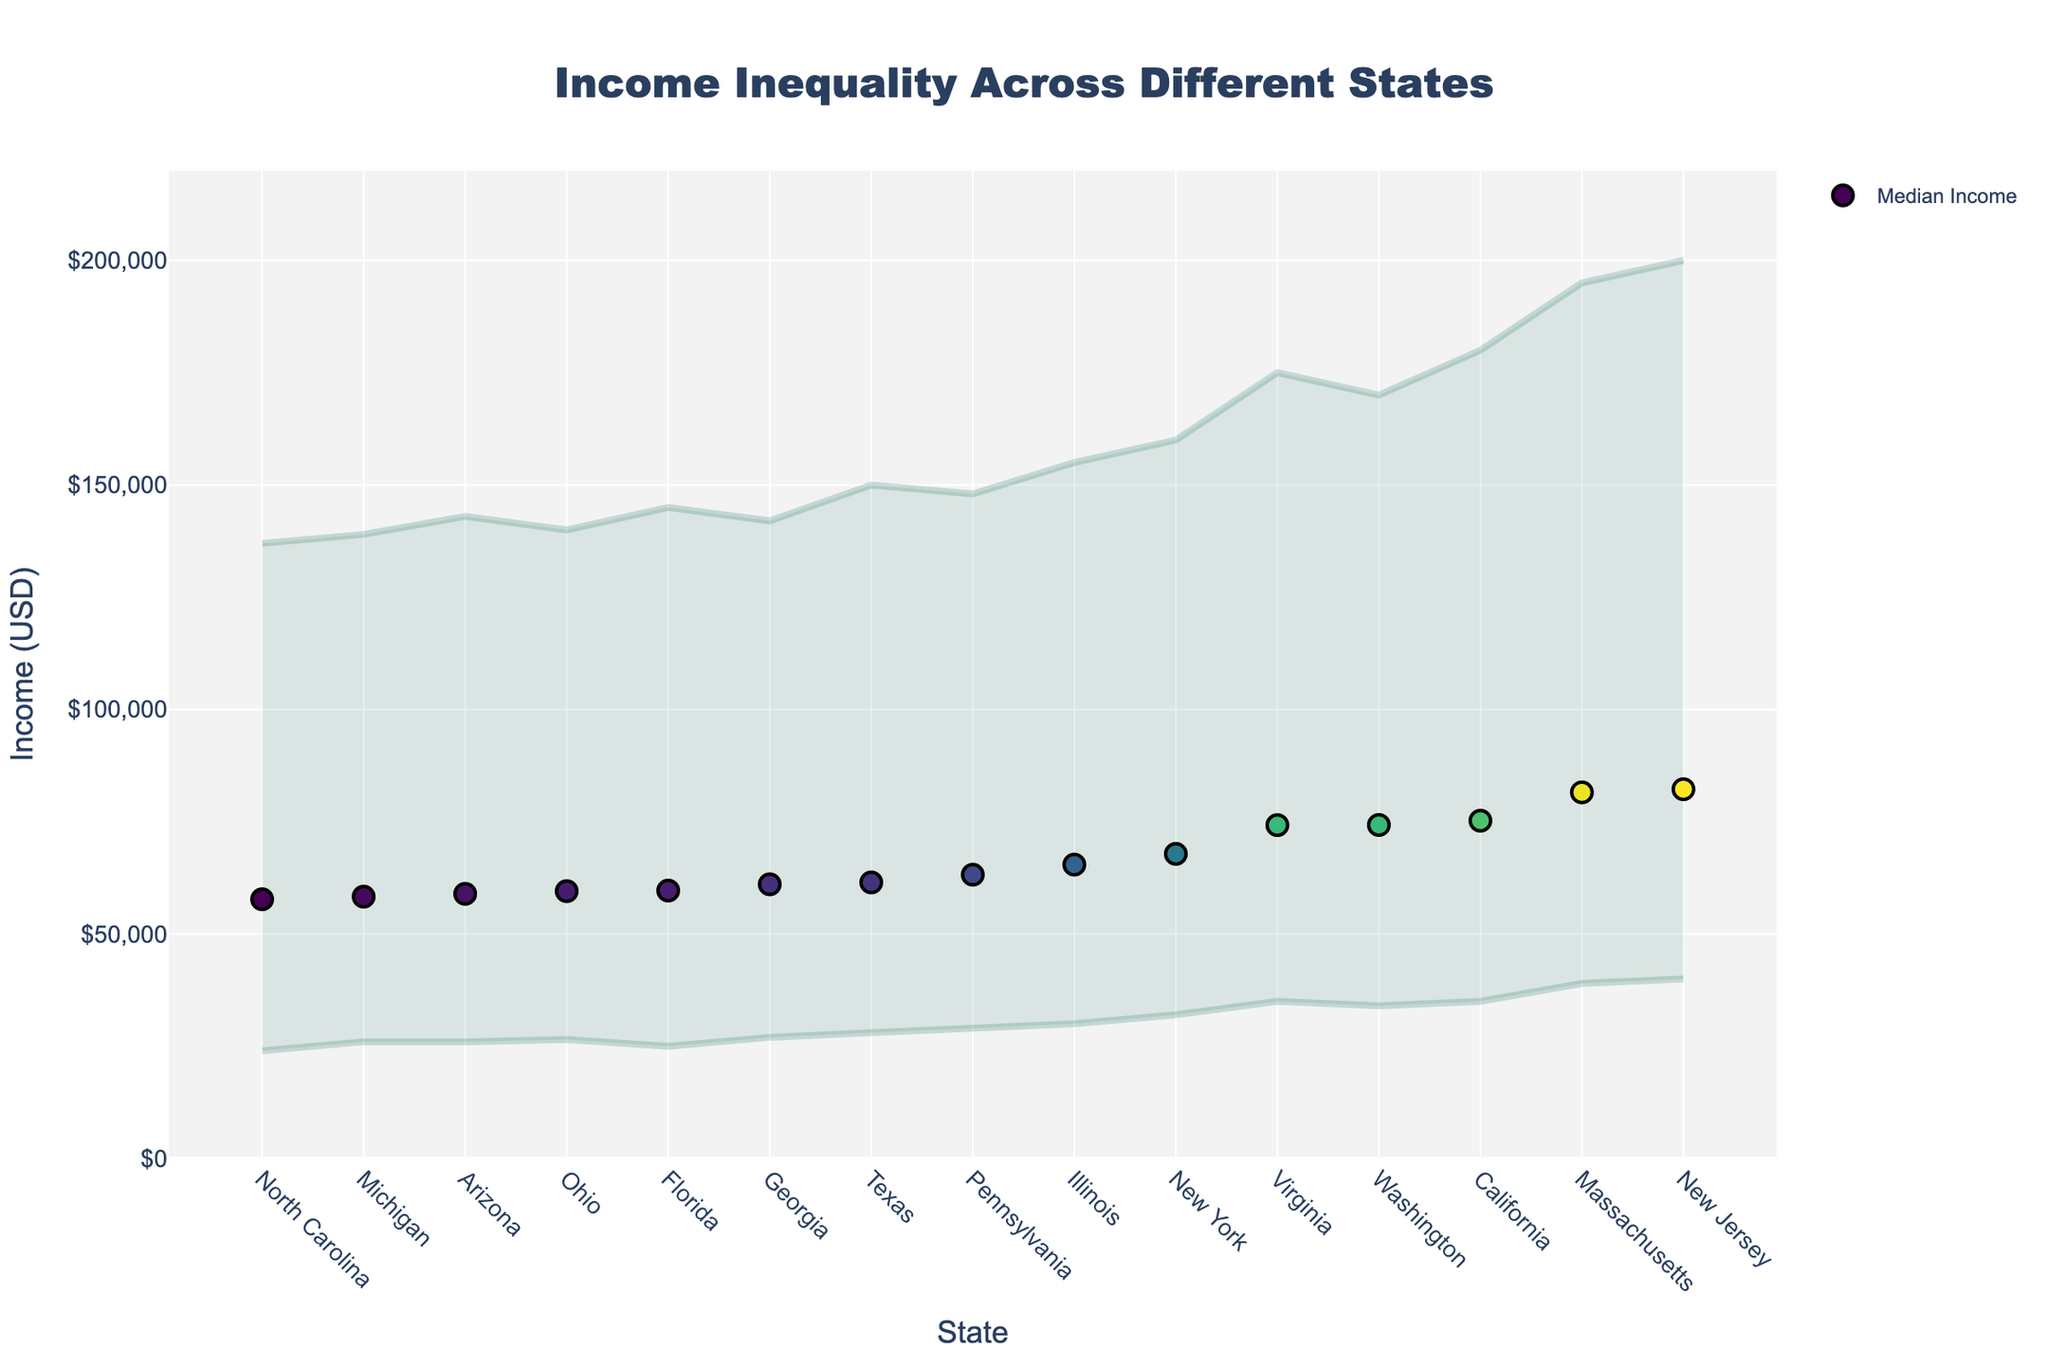what is the title of the figure? The title is usually located at the top of the graph. In this figure, it is clearly stated at the forefront.
Answer: Income Inequality Across Different States Which state has the highest median household income? To find the state with the highest median household income, look for the largest value of the median income on the vertical axis.
Answer: New Jersey What is the median household income for Texas? Locate Texas on the x-axis and then trace upwards to the point corresponding to the median household income.
Answer: \$61,485 Which state has the largest income range? Compare the lengths of the ranges for each state. The longest line indicates the largest range.
Answer: New Jersey What is the difference between the median household income of California and Florida? Subtract the median household income of Florida from that of California.
Answer: \$15,560 (75,235 - 59,675) Which states have a median household income higher than $75,000? Identify all states with a median household income above the $75,000 mark on the vertical axis.
Answer: California, New Jersey, Massachusetts, Virginia What is the income range for Pennsylvania? Locate Pennsylvania on the x-axis and identify the income range indicated.
Answer: \$29,000 - \$148,000 How does the median household income of Ohio compare to the overall range of Florida? Trace the median household income for Ohio and check if it falls within the range indicated for Florida.
Answer: Within range What’s the average median household income of New York and Illinois? Sum the median household incomes of New York and Illinois then divide by two.
Answer: \$66,650 (67,845 + 65,455) / 2 Which state has the smallest income range, and what is it? Locate the shortest income range amongst all states by visually inspecting the lengths of the lines.
Answer: North Carolina, \$113,000 (137,000 - 24,000) 